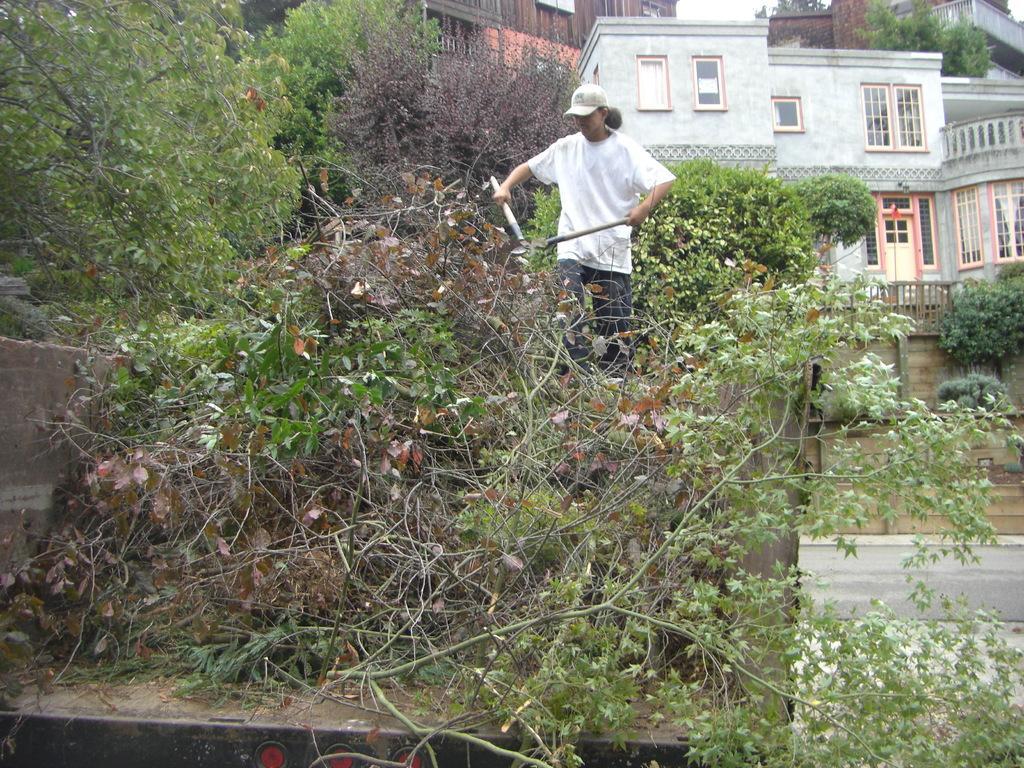Can you describe this image briefly? In this image I can see a person wearing white t shirt, cap and pant is standing and holding an object in hands. I can see few trees which are green and brown in color and few buildings. In the background I can see the sky. 